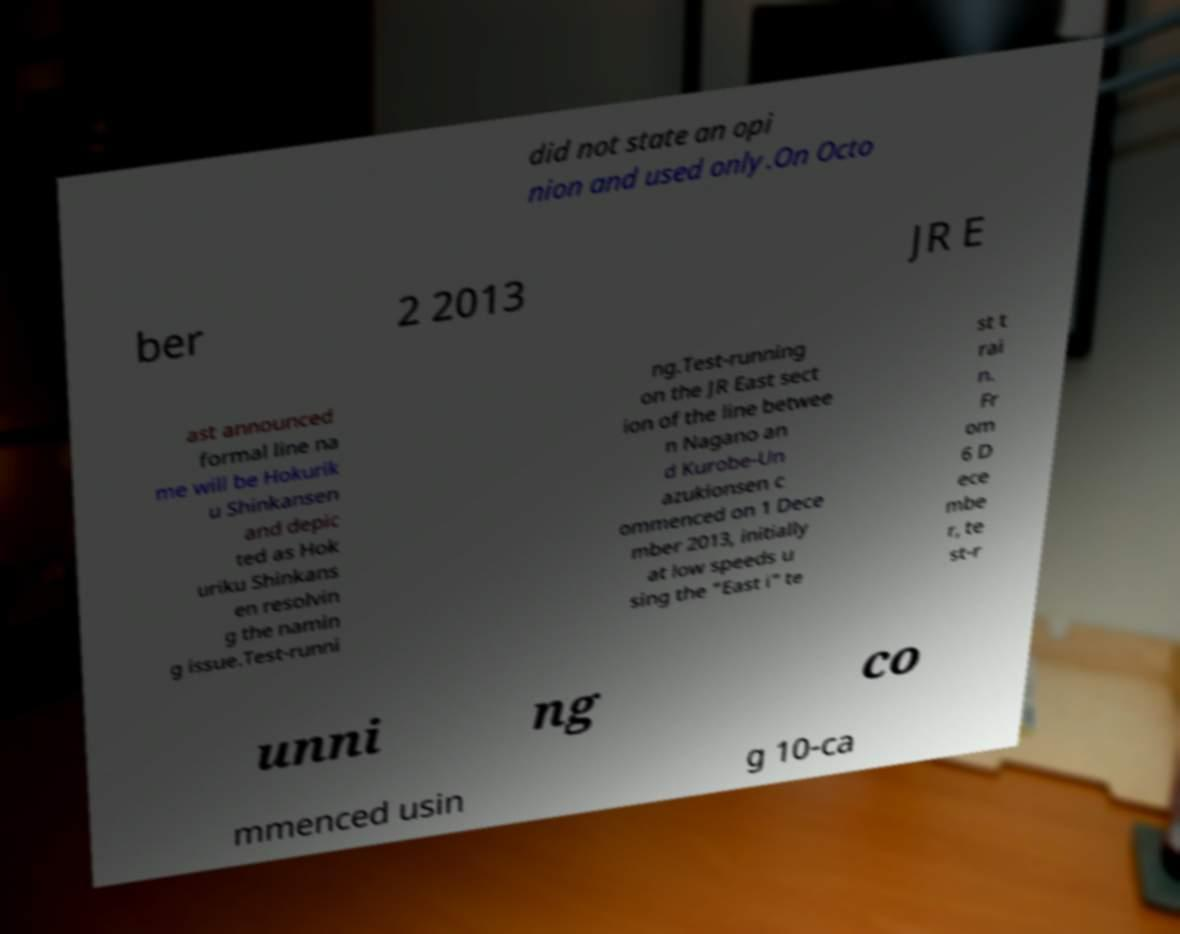Can you read and provide the text displayed in the image?This photo seems to have some interesting text. Can you extract and type it out for me? did not state an opi nion and used only.On Octo ber 2 2013 JR E ast announced formal line na me will be Hokurik u Shinkansen and depic ted as Hok uriku Shinkans en resolvin g the namin g issue.Test-runni ng.Test-running on the JR East sect ion of the line betwee n Nagano an d Kurobe-Un azukionsen c ommenced on 1 Dece mber 2013, initially at low speeds u sing the "East i" te st t rai n. Fr om 6 D ece mbe r, te st-r unni ng co mmenced usin g 10-ca 